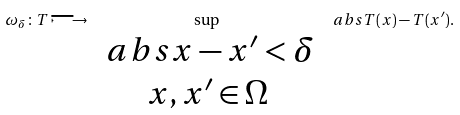Convert formula to latex. <formula><loc_0><loc_0><loc_500><loc_500>\omega _ { \delta } \colon T \longmapsto \sup _ { \begin{array} { c } \ a b s { x - x ^ { \prime } } < \delta \\ x , x ^ { \prime } \in \Omega \end{array} } \ a b s { T ( x ) - T ( x ^ { \prime } ) } .</formula> 